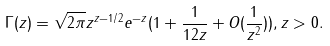Convert formula to latex. <formula><loc_0><loc_0><loc_500><loc_500>\Gamma ( z ) = \sqrt { 2 \pi } z ^ { z - 1 / 2 } e ^ { - z } ( 1 + \frac { 1 } { 1 2 z } + O ( \frac { 1 } { z ^ { 2 } } ) ) , z > 0 .</formula> 